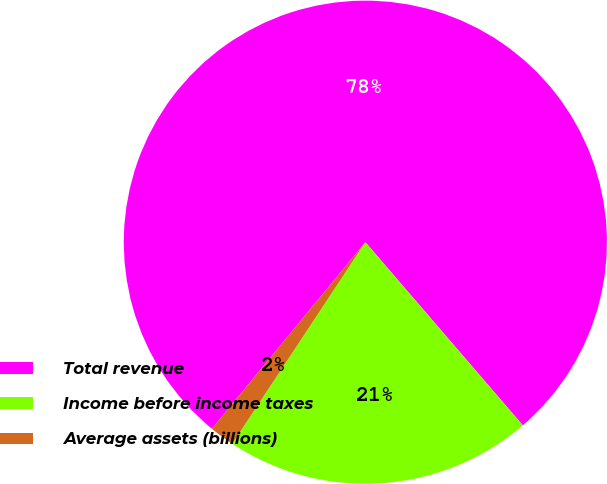Convert chart to OTSL. <chart><loc_0><loc_0><loc_500><loc_500><pie_chart><fcel>Total revenue<fcel>Income before income taxes<fcel>Average assets (billions)<nl><fcel>77.74%<fcel>20.59%<fcel>1.67%<nl></chart> 